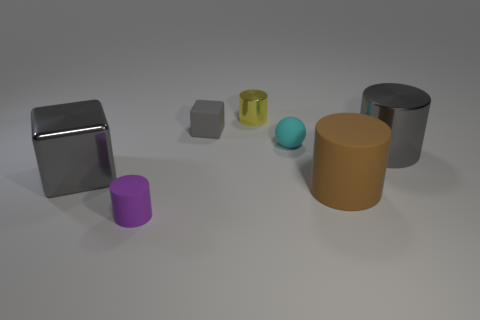There is a matte object that is to the right of the sphere; is it the same size as the gray cylinder?
Your response must be concise. Yes. Are there any big cubes that have the same color as the sphere?
Make the answer very short. No. How many objects are either gray things to the left of the tiny purple object or big gray shiny objects that are to the left of the tiny cyan rubber thing?
Give a very brief answer. 1. Do the small matte sphere and the tiny rubber cylinder have the same color?
Ensure brevity in your answer.  No. What is the material of the cylinder that is the same color as the big shiny block?
Offer a terse response. Metal. Are there fewer small gray rubber objects on the left side of the purple cylinder than tiny yellow objects that are right of the large brown matte cylinder?
Give a very brief answer. No. Are the big cube and the small cyan ball made of the same material?
Give a very brief answer. No. What size is the rubber object that is behind the brown matte cylinder and to the left of the tiny yellow cylinder?
Offer a terse response. Small. The yellow metal object that is the same size as the purple rubber object is what shape?
Offer a terse response. Cylinder. The small cylinder that is behind the tiny rubber object that is in front of the big cylinder that is behind the large brown rubber thing is made of what material?
Your answer should be compact. Metal. 